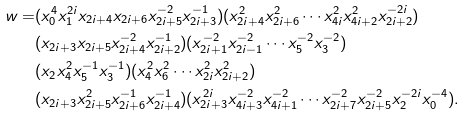<formula> <loc_0><loc_0><loc_500><loc_500>w = & ( x _ { 0 } ^ { 4 } x _ { 1 } ^ { 2 i } x _ { 2 i + 4 } x _ { 2 i + 6 } x _ { 2 i + 5 } ^ { - 2 } x _ { 2 i + 3 } ^ { - 1 } ) ( x _ { 2 i + 4 } ^ { 2 } x _ { 2 i + 6 } ^ { 2 } \cdots x _ { 4 i } ^ { 2 } x _ { 4 i + 2 } ^ { 2 } x _ { 2 i + 2 } ^ { - 2 i } ) \\ & ( x _ { 2 i + 3 } x _ { 2 i + 5 } x _ { 2 i + 4 } ^ { - 2 } x _ { 2 i + 2 } ^ { - 1 } ) ( x _ { 2 i + 1 } ^ { - 2 } x _ { 2 i - 1 } ^ { - 2 } \cdots x _ { 5 } ^ { - 2 } x _ { 3 } ^ { - 2 } ) \\ & ( x _ { 2 } x _ { 4 } ^ { 2 } x _ { 5 } ^ { - 1 } x _ { 3 } ^ { - 1 } ) ( x _ { 4 } ^ { 2 } x _ { 6 } ^ { 2 } \cdots x _ { 2 i } ^ { 2 } x _ { 2 i + 2 } ^ { 2 } ) \\ & ( x _ { 2 i + 3 } x _ { 2 i + 5 } ^ { 2 } x _ { 2 i + 6 } ^ { - 1 } x _ { 2 i + 4 } ^ { - 1 } ) ( x _ { 2 i + 3 } ^ { 2 i } x _ { 4 i + 3 } ^ { - 2 } x _ { 4 i + 1 } ^ { - 2 } \cdots x _ { 2 i + 7 } ^ { - 2 } x _ { 2 i + 5 } ^ { - 2 } x _ { 2 } ^ { - 2 i } x _ { 0 } ^ { - 4 } ) .</formula> 